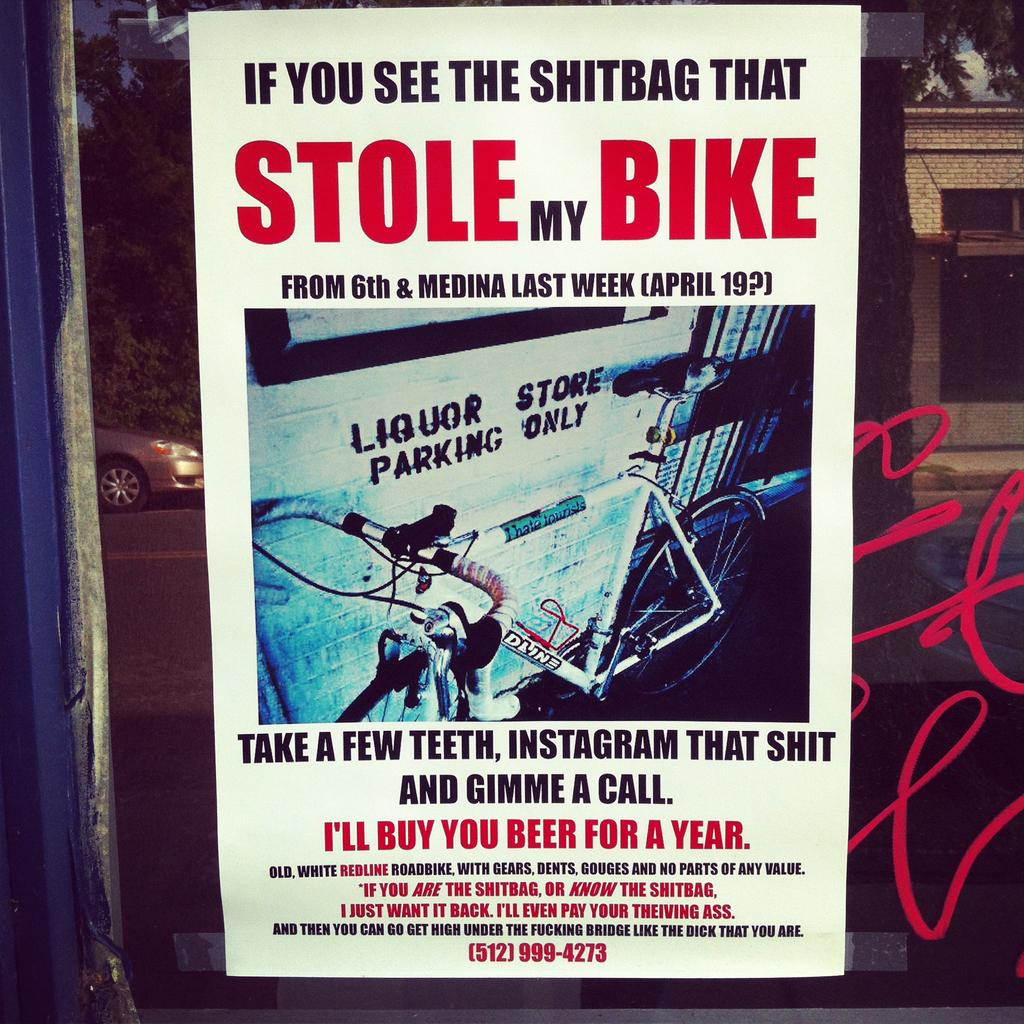Provide a one-sentence caption for the provided image. Poster of someone looking for the person that Stole their Bike. 